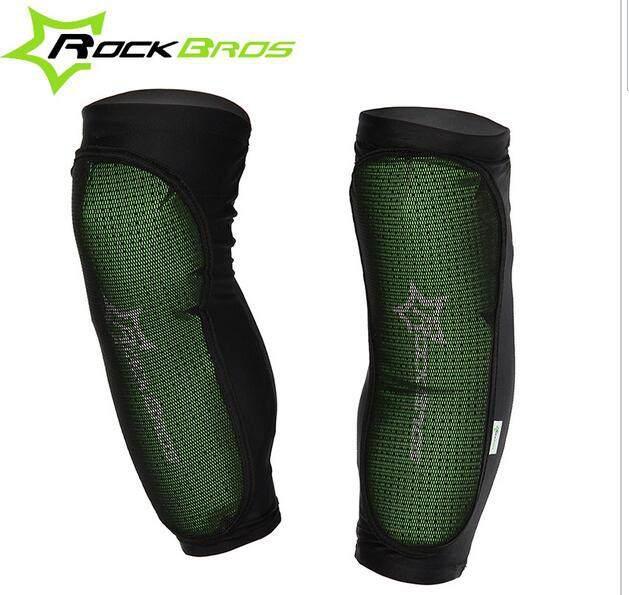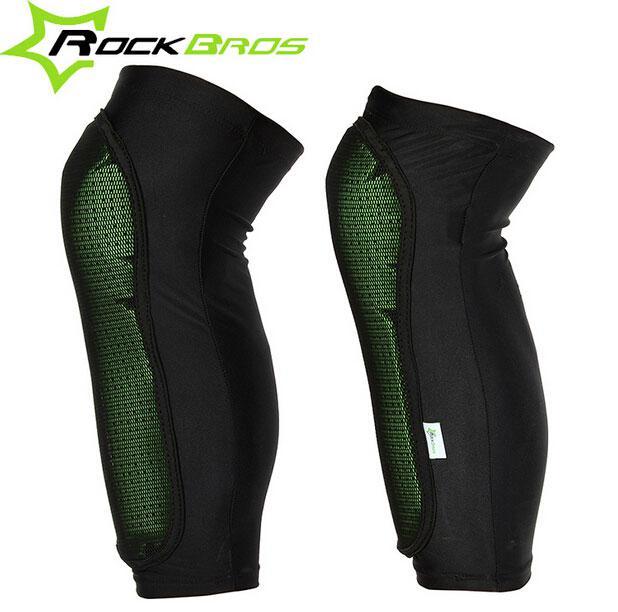The first image is the image on the left, the second image is the image on the right. For the images displayed, is the sentence "There are two pairs of legs and two pairs of leg braces." factually correct? Answer yes or no. No. 